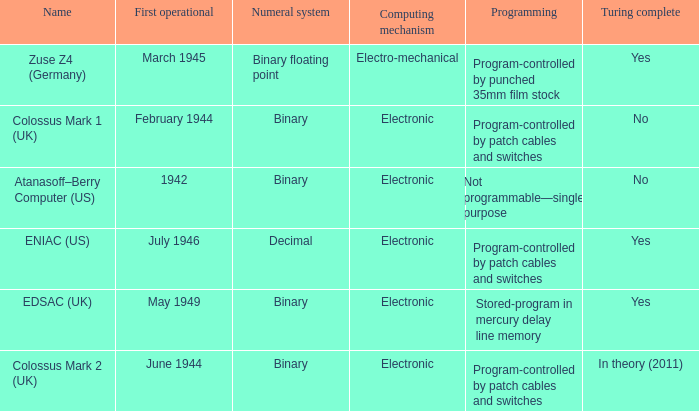What's the computing mechanbeingm with name being atanasoff–berry computer (us) Electronic. 